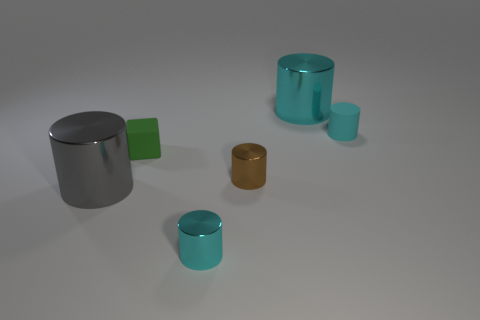What is the shape of the object that is the same size as the gray shiny cylinder?
Provide a short and direct response. Cylinder. There is a big cyan metallic object; are there any cylinders to the right of it?
Provide a succinct answer. Yes. There is a big cylinder that is on the left side of the small green matte cube; is there a tiny metallic thing in front of it?
Your response must be concise. Yes. Is the number of small matte blocks on the right side of the rubber cylinder less than the number of tiny things that are on the left side of the tiny brown shiny thing?
Provide a short and direct response. Yes. What is the shape of the green matte thing?
Provide a short and direct response. Cube. What is the material of the tiny object in front of the tiny brown metal cylinder?
Your response must be concise. Metal. There is a cyan shiny thing that is behind the cylinder to the left of the cyan cylinder that is in front of the cube; how big is it?
Provide a succinct answer. Large. Are the small cyan cylinder behind the small matte block and the small green thing in front of the matte cylinder made of the same material?
Your answer should be very brief. Yes. What number of other objects are the same color as the tiny cube?
Make the answer very short. 0. What number of things are either big cylinders left of the small cyan shiny cylinder or big objects that are on the left side of the tiny green rubber thing?
Ensure brevity in your answer.  1. 